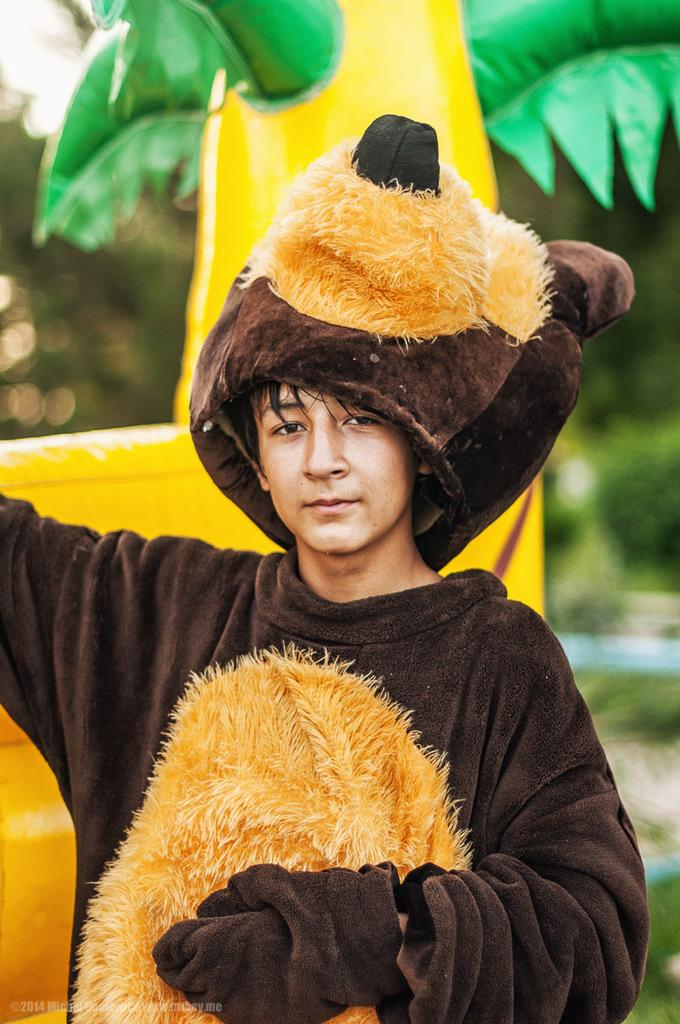Who or what is present in the image? There is a person in the image. What is the person wearing? The person is wearing woolen cloth shaped like a teddy bear. What can be seen in the background of the image? There are toys and trees in the background of the image. What type of coal is being used to decorate the teddy bear costume? There is no coal present in the image; the person is wearing woolen cloth shaped like a teddy bear. What kind of jewel can be seen on the person's forehead in the image? There is no jewel present on the person's forehead in the image. 